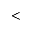Convert formula to latex. <formula><loc_0><loc_0><loc_500><loc_500><</formula> 